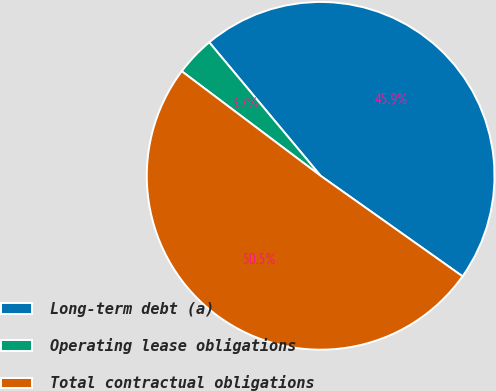Convert chart. <chart><loc_0><loc_0><loc_500><loc_500><pie_chart><fcel>Long-term debt (a)<fcel>Operating lease obligations<fcel>Total contractual obligations<nl><fcel>45.87%<fcel>3.66%<fcel>50.46%<nl></chart> 